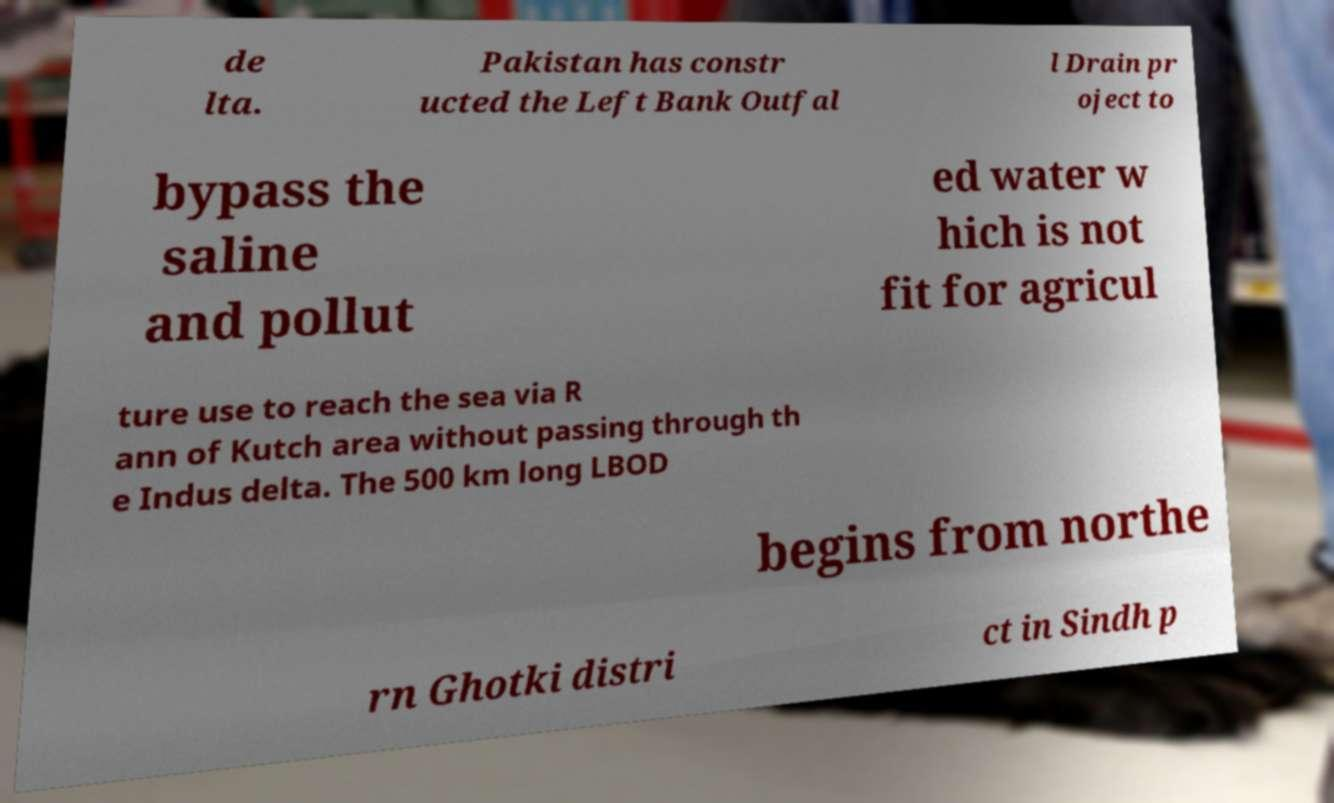Could you extract and type out the text from this image? de lta. Pakistan has constr ucted the Left Bank Outfal l Drain pr oject to bypass the saline and pollut ed water w hich is not fit for agricul ture use to reach the sea via R ann of Kutch area without passing through th e Indus delta. The 500 km long LBOD begins from northe rn Ghotki distri ct in Sindh p 